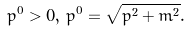<formula> <loc_0><loc_0><loc_500><loc_500>p ^ { 0 } > 0 , \, p ^ { 0 } = \sqrt { p ^ { 2 } + m ^ { 2 } } .</formula> 